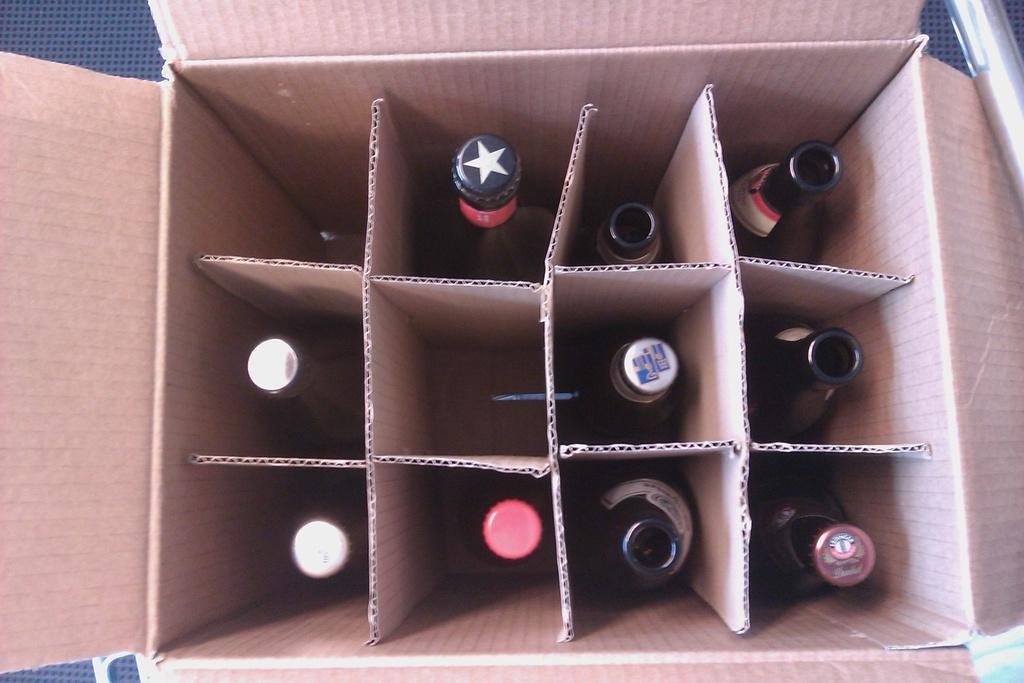What is the main object in the image? There is a box in the image. What can be found inside the box? There are bottles inside the box. What type of sail is attached to the box in the image? There is no sail attached to the box in the image. How many jars can be seen inside the box? There is no mention of jars in the image; only bottles are mentioned. 